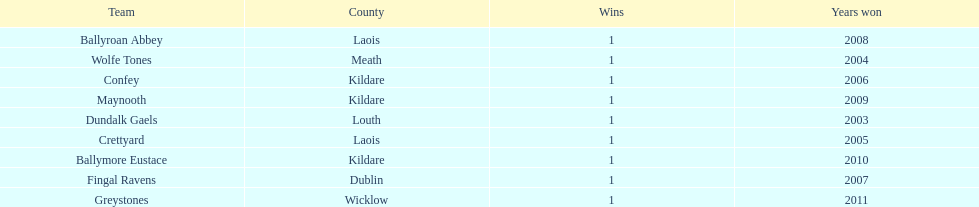Which team won after ballymore eustace? Greystones. 